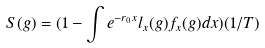<formula> <loc_0><loc_0><loc_500><loc_500>S ( g ) = ( 1 - \int e ^ { - r _ { 0 } x } l _ { x } ( g ) f _ { x } ( g ) d x ) ( 1 / T )</formula> 